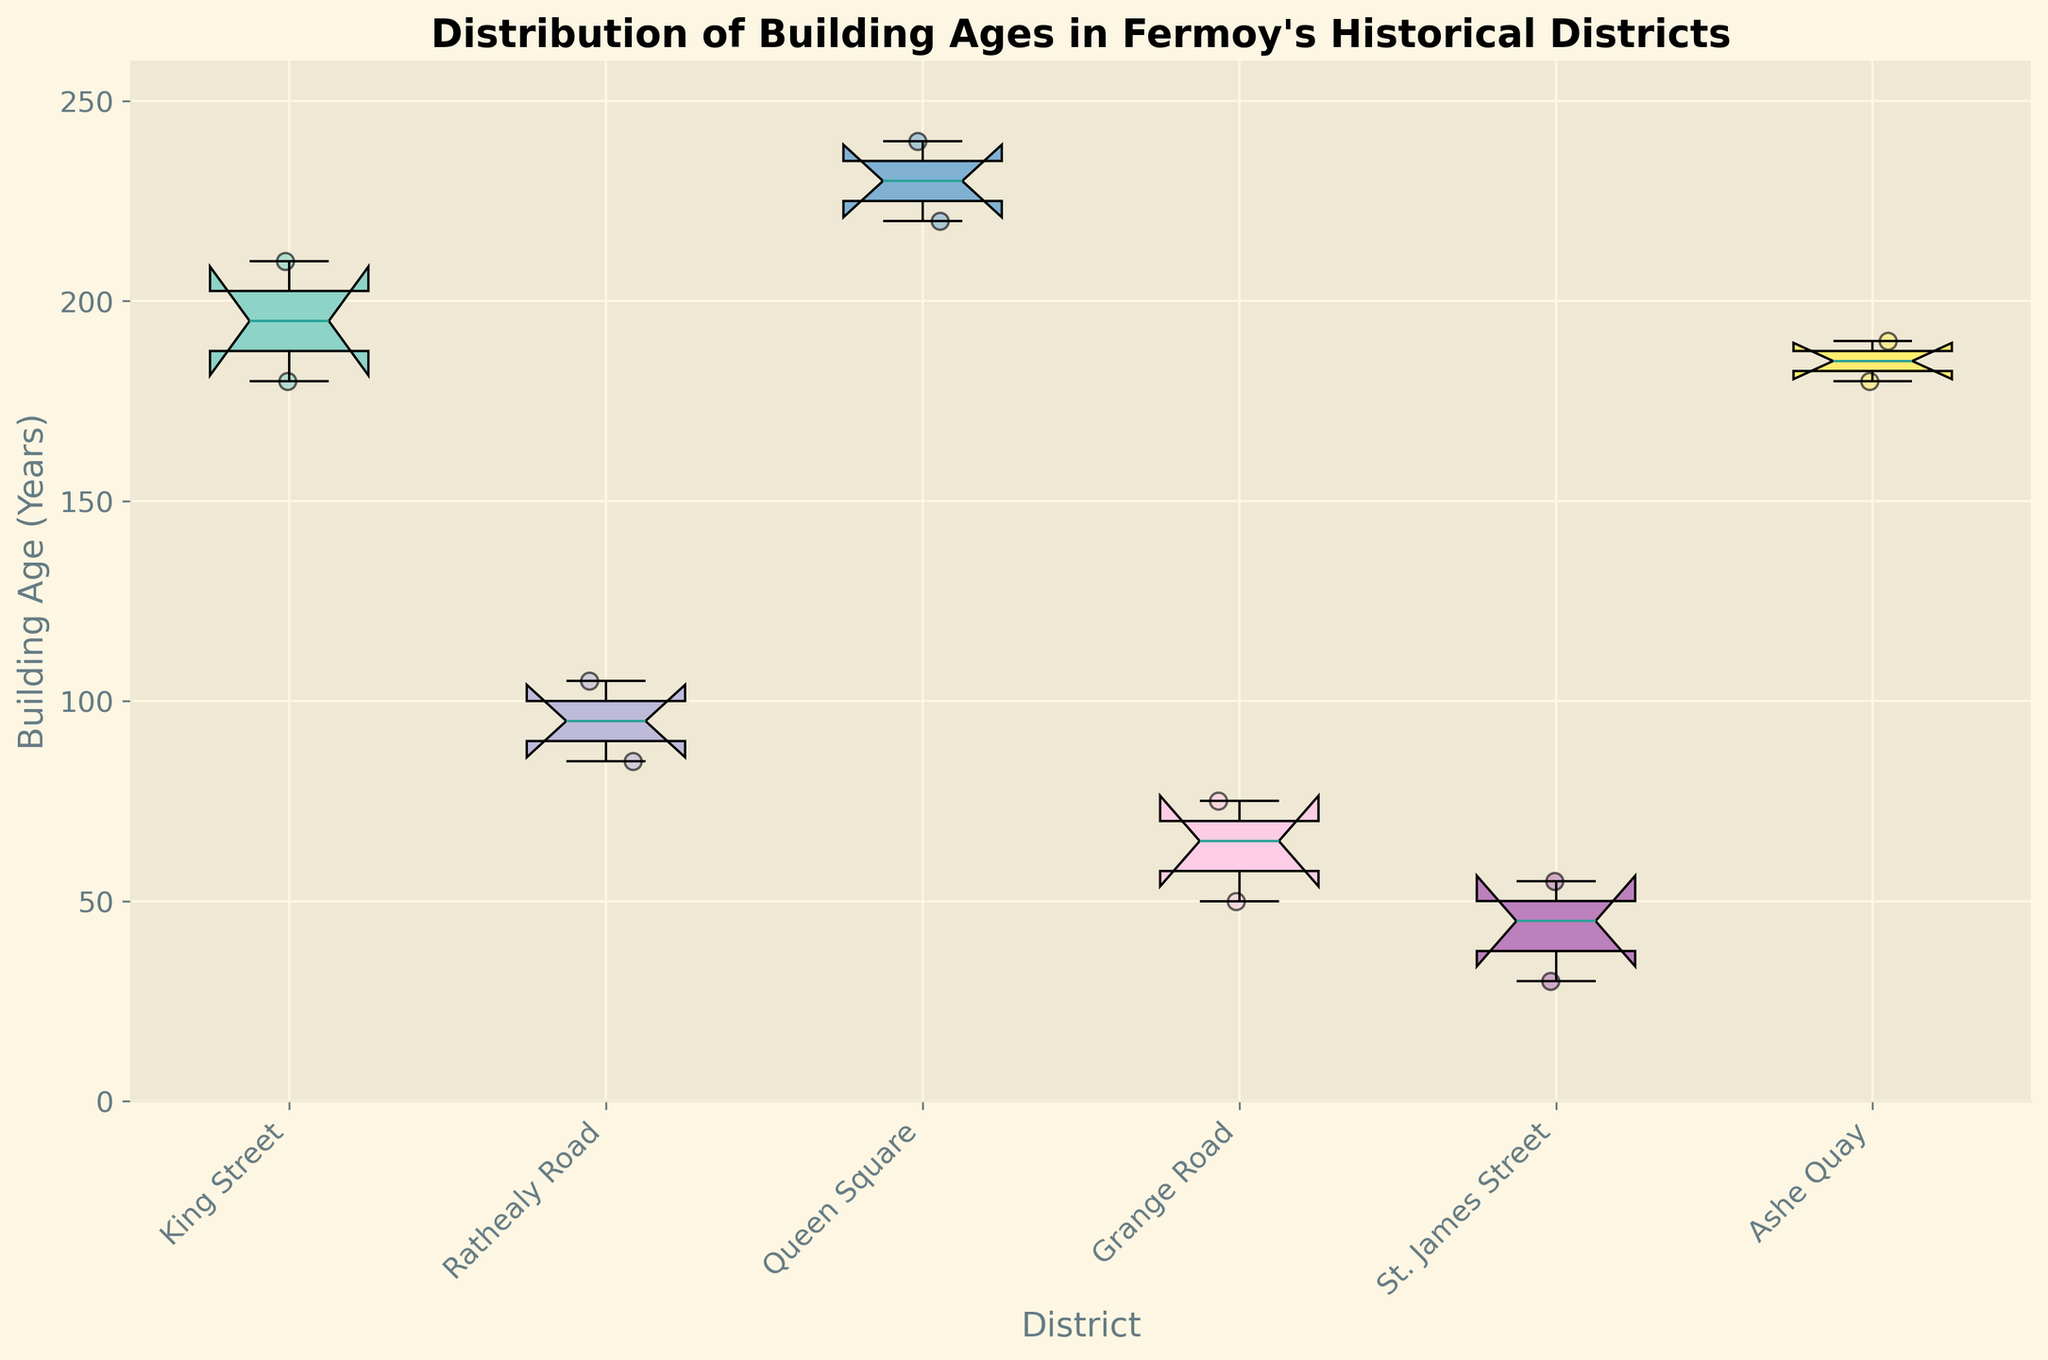What is the median building age in King Street? The notched box plot indicates medians as notches in the boxes. For King Street, the median notch falls around 195 years.
Answer: 195 years How many data points are there for Queen Square? The scatter plot points representing individual values provide this information. There are three points visible for Queen Square.
Answer: 3 Which district has the oldest building based on the diagram? By inspecting the maximum values protruding from the top of the whiskers, Queen Square has the oldest building, approximately 240 years old.
Answer: Queen Square Which district shows the largest spread in building ages? The spread is evident from the length of the boxes and whiskers. Queen Square has the largest spread, ranging from around 220 to 240 years.
Answer: Queen Square What is the interquartile range (IQR) for Grange Road? The IQR is the range covered by the box. For Grange Road, it spans from about 50 to 75 years. The IQR is 75 - 50 = 25 years.
Answer: 25 years Is the youngest building in Ashe Quay younger than the youngest building in St. James Street? Comparing the minimum whiskers shows Ashe Quay's minimum at around 180 years while St. James Street's minimum is around 30 years.
Answer: No Which district has the smallest median building age? By observing the notches, St. James Street has the smallest median building age, around 45 years.
Answer: St. James Street What is the average of the medians of Queen Square, St. James Street, and King Street? The median values for these districts are 230, 45, and 195 years respectively. Average = (230 + 45 + 195) / 3 = 470 / 3 ≈ 156.67 years.
Answer: 156.67 years Are any of the districts' medians below 100 years? The notches around the boxes of each district do not reach below 100 years except for St. James Street which is at around 45 years.
Answer: Yes Which district has the most consistent building age, based on the smallest interquartile range (IQR)? The district with the smallest IQR can be seen from the shortest box length. Rathealy Road has the smallest IQR, approximately 10 years.
Answer: Rathealy Road 